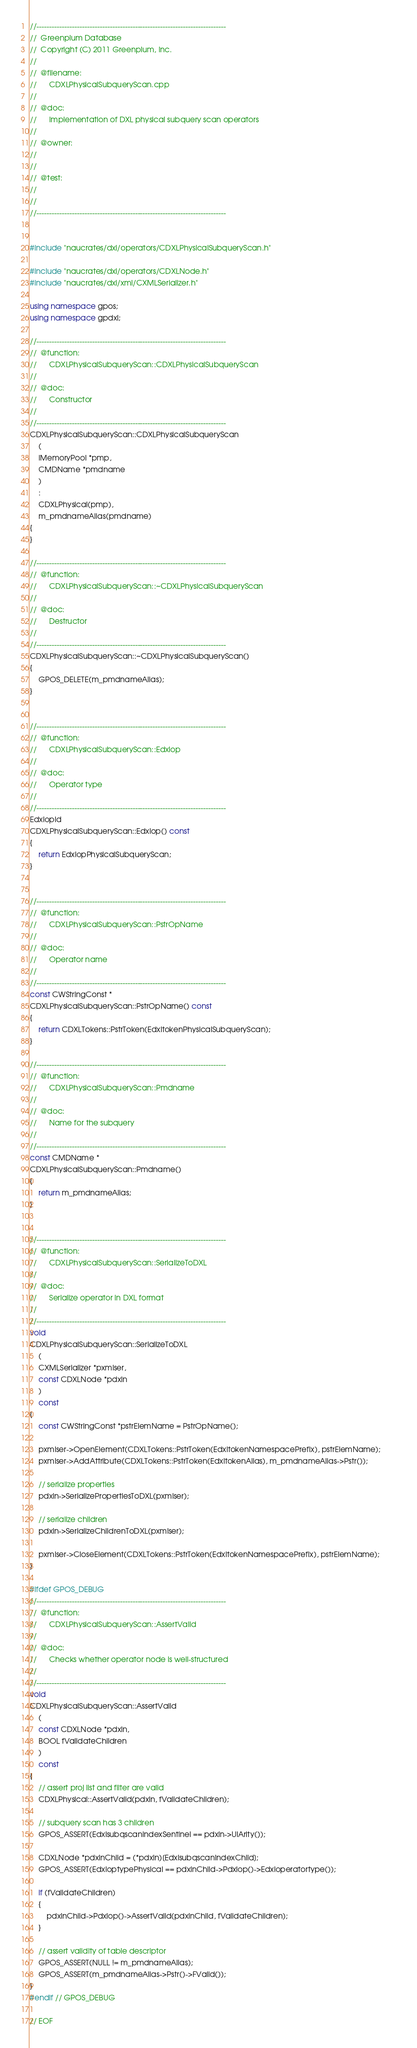<code> <loc_0><loc_0><loc_500><loc_500><_C++_>//---------------------------------------------------------------------------
//	Greenplum Database
//	Copyright (C) 2011 Greenplum, Inc.
//
//	@filename:
//		CDXLPhysicalSubqueryScan.cpp
//
//	@doc:
//		Implementation of DXL physical subquery scan operators
//
//	@owner: 
//		
//
//	@test:
//
//
//---------------------------------------------------------------------------


#include "naucrates/dxl/operators/CDXLPhysicalSubqueryScan.h"

#include "naucrates/dxl/operators/CDXLNode.h"
#include "naucrates/dxl/xml/CXMLSerializer.h"

using namespace gpos;
using namespace gpdxl;

//---------------------------------------------------------------------------
//	@function:
//		CDXLPhysicalSubqueryScan::CDXLPhysicalSubqueryScan
//
//	@doc:
//		Constructor
//
//---------------------------------------------------------------------------
CDXLPhysicalSubqueryScan::CDXLPhysicalSubqueryScan
	(
	IMemoryPool *pmp,
	CMDName *pmdname
	)
	:
	CDXLPhysical(pmp),
	m_pmdnameAlias(pmdname)
{
}

//---------------------------------------------------------------------------
//	@function:
//		CDXLPhysicalSubqueryScan::~CDXLPhysicalSubqueryScan
//
//	@doc:
//		Destructor
//
//---------------------------------------------------------------------------
CDXLPhysicalSubqueryScan::~CDXLPhysicalSubqueryScan()
{
	GPOS_DELETE(m_pmdnameAlias);
}


//---------------------------------------------------------------------------
//	@function:
//		CDXLPhysicalSubqueryScan::Edxlop
//
//	@doc:
//		Operator type
//
//---------------------------------------------------------------------------
Edxlopid
CDXLPhysicalSubqueryScan::Edxlop() const
{
	return EdxlopPhysicalSubqueryScan;
}


//---------------------------------------------------------------------------
//	@function:
//		CDXLPhysicalSubqueryScan::PstrOpName
//
//	@doc:
//		Operator name
//
//---------------------------------------------------------------------------
const CWStringConst *
CDXLPhysicalSubqueryScan::PstrOpName() const
{
	return CDXLTokens::PstrToken(EdxltokenPhysicalSubqueryScan);
}

//---------------------------------------------------------------------------
//	@function:
//		CDXLPhysicalSubqueryScan::Pmdname
//
//	@doc:
//		Name for the subquery
//
//---------------------------------------------------------------------------
const CMDName *
CDXLPhysicalSubqueryScan::Pmdname()
{
	return m_pmdnameAlias;
}


//---------------------------------------------------------------------------
//	@function:
//		CDXLPhysicalSubqueryScan::SerializeToDXL
//
//	@doc:
//		Serialize operator in DXL format
//
//---------------------------------------------------------------------------
void
CDXLPhysicalSubqueryScan::SerializeToDXL
	(
	CXMLSerializer *pxmlser,
	const CDXLNode *pdxln
	)
	const
{
	const CWStringConst *pstrElemName = PstrOpName();
	
	pxmlser->OpenElement(CDXLTokens::PstrToken(EdxltokenNamespacePrefix), pstrElemName);
	pxmlser->AddAttribute(CDXLTokens::PstrToken(EdxltokenAlias), m_pmdnameAlias->Pstr());
	
	// serialize properties
	pdxln->SerializePropertiesToDXL(pxmlser);
	
	// serialize children
	pdxln->SerializeChildrenToDXL(pxmlser);
		
	pxmlser->CloseElement(CDXLTokens::PstrToken(EdxltokenNamespacePrefix), pstrElemName);		
}

#ifdef GPOS_DEBUG
//---------------------------------------------------------------------------
//	@function:
//		CDXLPhysicalSubqueryScan::AssertValid
//
//	@doc:
//		Checks whether operator node is well-structured 
//
//---------------------------------------------------------------------------
void
CDXLPhysicalSubqueryScan::AssertValid
	(
	const CDXLNode *pdxln,
	BOOL fValidateChildren
	) 
	const
{
	// assert proj list and filter are valid
	CDXLPhysical::AssertValid(pdxln, fValidateChildren);
	
	// subquery scan has 3 children
	GPOS_ASSERT(EdxlsubqscanIndexSentinel == pdxln->UlArity());
	
	CDXLNode *pdxlnChild = (*pdxln)[EdxlsubqscanIndexChild];
	GPOS_ASSERT(EdxloptypePhysical == pdxlnChild->Pdxlop()->Edxloperatortype());
	
	if (fValidateChildren)
	{
		pdxlnChild->Pdxlop()->AssertValid(pdxlnChild, fValidateChildren);
	}
	
	// assert validity of table descriptor
	GPOS_ASSERT(NULL != m_pmdnameAlias);
	GPOS_ASSERT(m_pmdnameAlias->Pstr()->FValid());
}
#endif // GPOS_DEBUG

// EOF
</code> 